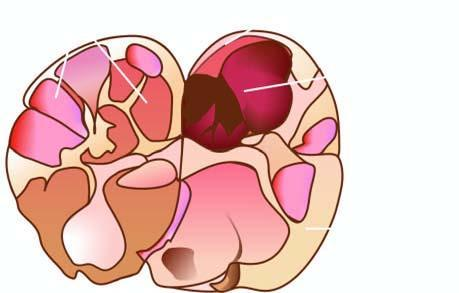what does sectioned surface of the thyroid show?
Answer the question using a single word or phrase. A solitary nodule having capsule 